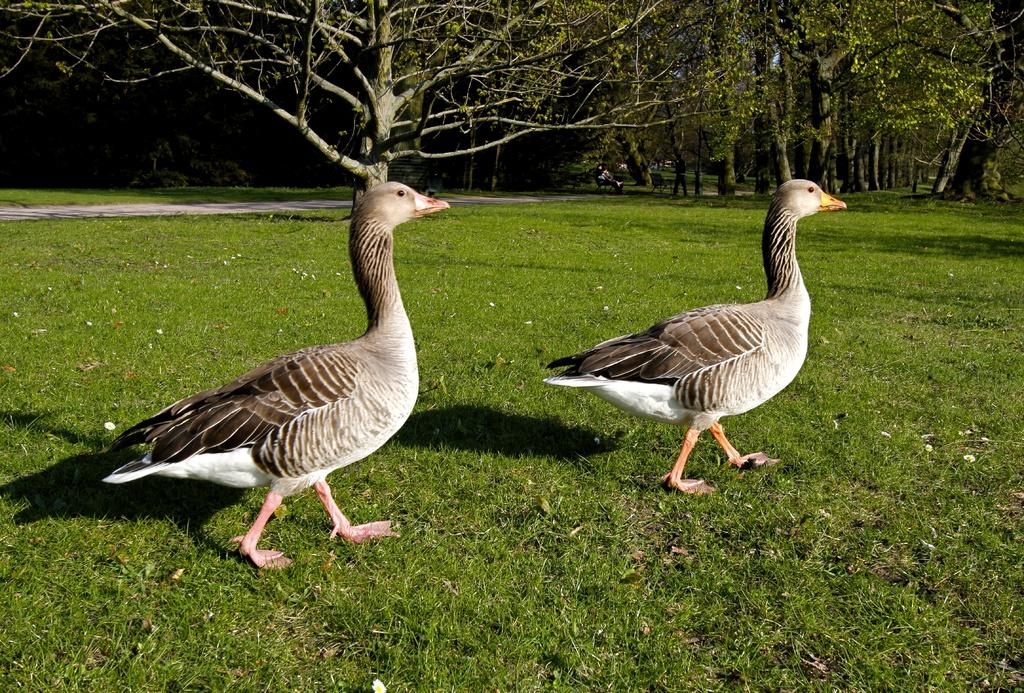What is on the ground in the image? There are birds on the ground in the image. What colors are the birds? The birds are in white and ash colors. What can be seen in the background of the image? There are many trees in the background of the image. What type of power source is visible in the image? There is no power source visible in the image; it features birds on the ground and trees in the background. What type of jeans are the birds wearing in the image? Birds do not wear jeans, so this detail cannot be found in the image. 